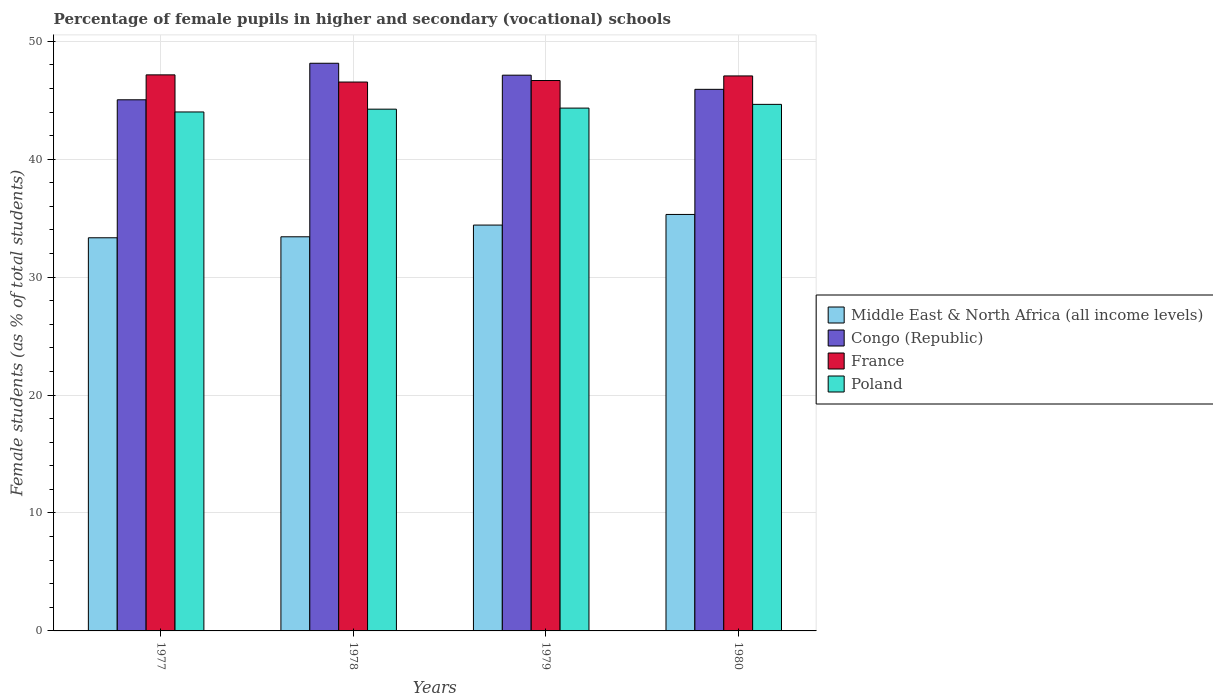How many groups of bars are there?
Provide a short and direct response. 4. Are the number of bars on each tick of the X-axis equal?
Ensure brevity in your answer.  Yes. How many bars are there on the 2nd tick from the left?
Keep it short and to the point. 4. In how many cases, is the number of bars for a given year not equal to the number of legend labels?
Provide a short and direct response. 0. What is the percentage of female pupils in higher and secondary schools in Middle East & North Africa (all income levels) in 1980?
Provide a succinct answer. 35.31. Across all years, what is the maximum percentage of female pupils in higher and secondary schools in Middle East & North Africa (all income levels)?
Offer a very short reply. 35.31. Across all years, what is the minimum percentage of female pupils in higher and secondary schools in Congo (Republic)?
Provide a short and direct response. 45.04. In which year was the percentage of female pupils in higher and secondary schools in Poland maximum?
Offer a terse response. 1980. In which year was the percentage of female pupils in higher and secondary schools in France minimum?
Provide a short and direct response. 1978. What is the total percentage of female pupils in higher and secondary schools in France in the graph?
Offer a terse response. 187.42. What is the difference between the percentage of female pupils in higher and secondary schools in Congo (Republic) in 1977 and that in 1979?
Ensure brevity in your answer.  -2.09. What is the difference between the percentage of female pupils in higher and secondary schools in Middle East & North Africa (all income levels) in 1977 and the percentage of female pupils in higher and secondary schools in Congo (Republic) in 1978?
Offer a very short reply. -14.8. What is the average percentage of female pupils in higher and secondary schools in Congo (Republic) per year?
Provide a short and direct response. 46.55. In the year 1979, what is the difference between the percentage of female pupils in higher and secondary schools in Congo (Republic) and percentage of female pupils in higher and secondary schools in Middle East & North Africa (all income levels)?
Provide a short and direct response. 12.71. In how many years, is the percentage of female pupils in higher and secondary schools in France greater than 42 %?
Provide a succinct answer. 4. What is the ratio of the percentage of female pupils in higher and secondary schools in France in 1979 to that in 1980?
Your answer should be compact. 0.99. What is the difference between the highest and the second highest percentage of female pupils in higher and secondary schools in Congo (Republic)?
Your response must be concise. 1.01. What is the difference between the highest and the lowest percentage of female pupils in higher and secondary schools in Poland?
Give a very brief answer. 0.64. In how many years, is the percentage of female pupils in higher and secondary schools in Congo (Republic) greater than the average percentage of female pupils in higher and secondary schools in Congo (Republic) taken over all years?
Ensure brevity in your answer.  2. Is it the case that in every year, the sum of the percentage of female pupils in higher and secondary schools in France and percentage of female pupils in higher and secondary schools in Middle East & North Africa (all income levels) is greater than the sum of percentage of female pupils in higher and secondary schools in Congo (Republic) and percentage of female pupils in higher and secondary schools in Poland?
Ensure brevity in your answer.  Yes. What does the 1st bar from the left in 1977 represents?
Make the answer very short. Middle East & North Africa (all income levels). What does the 3rd bar from the right in 1979 represents?
Give a very brief answer. Congo (Republic). How many years are there in the graph?
Give a very brief answer. 4. Where does the legend appear in the graph?
Your answer should be compact. Center right. How are the legend labels stacked?
Offer a terse response. Vertical. What is the title of the graph?
Your answer should be compact. Percentage of female pupils in higher and secondary (vocational) schools. What is the label or title of the X-axis?
Your answer should be compact. Years. What is the label or title of the Y-axis?
Offer a very short reply. Female students (as % of total students). What is the Female students (as % of total students) of Middle East & North Africa (all income levels) in 1977?
Your answer should be compact. 33.34. What is the Female students (as % of total students) in Congo (Republic) in 1977?
Give a very brief answer. 45.04. What is the Female students (as % of total students) of France in 1977?
Ensure brevity in your answer.  47.15. What is the Female students (as % of total students) in Poland in 1977?
Your answer should be compact. 44. What is the Female students (as % of total students) in Middle East & North Africa (all income levels) in 1978?
Make the answer very short. 33.42. What is the Female students (as % of total students) of Congo (Republic) in 1978?
Your response must be concise. 48.13. What is the Female students (as % of total students) of France in 1978?
Your answer should be very brief. 46.54. What is the Female students (as % of total students) in Poland in 1978?
Your response must be concise. 44.24. What is the Female students (as % of total students) in Middle East & North Africa (all income levels) in 1979?
Offer a very short reply. 34.41. What is the Female students (as % of total students) of Congo (Republic) in 1979?
Your answer should be compact. 47.12. What is the Female students (as % of total students) of France in 1979?
Ensure brevity in your answer.  46.67. What is the Female students (as % of total students) in Poland in 1979?
Provide a succinct answer. 44.33. What is the Female students (as % of total students) of Middle East & North Africa (all income levels) in 1980?
Make the answer very short. 35.31. What is the Female students (as % of total students) of Congo (Republic) in 1980?
Provide a succinct answer. 45.92. What is the Female students (as % of total students) of France in 1980?
Your response must be concise. 47.06. What is the Female students (as % of total students) in Poland in 1980?
Offer a very short reply. 44.65. Across all years, what is the maximum Female students (as % of total students) of Middle East & North Africa (all income levels)?
Make the answer very short. 35.31. Across all years, what is the maximum Female students (as % of total students) of Congo (Republic)?
Make the answer very short. 48.13. Across all years, what is the maximum Female students (as % of total students) in France?
Provide a succinct answer. 47.15. Across all years, what is the maximum Female students (as % of total students) of Poland?
Make the answer very short. 44.65. Across all years, what is the minimum Female students (as % of total students) in Middle East & North Africa (all income levels)?
Your answer should be compact. 33.34. Across all years, what is the minimum Female students (as % of total students) in Congo (Republic)?
Give a very brief answer. 45.04. Across all years, what is the minimum Female students (as % of total students) in France?
Your answer should be compact. 46.54. Across all years, what is the minimum Female students (as % of total students) of Poland?
Offer a very short reply. 44. What is the total Female students (as % of total students) of Middle East & North Africa (all income levels) in the graph?
Your answer should be compact. 136.48. What is the total Female students (as % of total students) in Congo (Republic) in the graph?
Make the answer very short. 186.21. What is the total Female students (as % of total students) in France in the graph?
Your answer should be very brief. 187.42. What is the total Female students (as % of total students) of Poland in the graph?
Keep it short and to the point. 177.23. What is the difference between the Female students (as % of total students) of Middle East & North Africa (all income levels) in 1977 and that in 1978?
Your answer should be very brief. -0.08. What is the difference between the Female students (as % of total students) of Congo (Republic) in 1977 and that in 1978?
Provide a succinct answer. -3.1. What is the difference between the Female students (as % of total students) in France in 1977 and that in 1978?
Ensure brevity in your answer.  0.61. What is the difference between the Female students (as % of total students) in Poland in 1977 and that in 1978?
Your answer should be very brief. -0.24. What is the difference between the Female students (as % of total students) in Middle East & North Africa (all income levels) in 1977 and that in 1979?
Give a very brief answer. -1.08. What is the difference between the Female students (as % of total students) in Congo (Republic) in 1977 and that in 1979?
Offer a terse response. -2.09. What is the difference between the Female students (as % of total students) in France in 1977 and that in 1979?
Make the answer very short. 0.48. What is the difference between the Female students (as % of total students) in Poland in 1977 and that in 1979?
Ensure brevity in your answer.  -0.33. What is the difference between the Female students (as % of total students) of Middle East & North Africa (all income levels) in 1977 and that in 1980?
Your answer should be very brief. -1.98. What is the difference between the Female students (as % of total students) of Congo (Republic) in 1977 and that in 1980?
Offer a terse response. -0.89. What is the difference between the Female students (as % of total students) in France in 1977 and that in 1980?
Offer a terse response. 0.09. What is the difference between the Female students (as % of total students) of Poland in 1977 and that in 1980?
Provide a short and direct response. -0.64. What is the difference between the Female students (as % of total students) in Middle East & North Africa (all income levels) in 1978 and that in 1979?
Offer a very short reply. -0.99. What is the difference between the Female students (as % of total students) of Congo (Republic) in 1978 and that in 1979?
Make the answer very short. 1.01. What is the difference between the Female students (as % of total students) of France in 1978 and that in 1979?
Offer a terse response. -0.13. What is the difference between the Female students (as % of total students) of Poland in 1978 and that in 1979?
Make the answer very short. -0.09. What is the difference between the Female students (as % of total students) in Middle East & North Africa (all income levels) in 1978 and that in 1980?
Provide a short and direct response. -1.89. What is the difference between the Female students (as % of total students) in Congo (Republic) in 1978 and that in 1980?
Make the answer very short. 2.21. What is the difference between the Female students (as % of total students) in France in 1978 and that in 1980?
Your response must be concise. -0.52. What is the difference between the Female students (as % of total students) in Poland in 1978 and that in 1980?
Ensure brevity in your answer.  -0.41. What is the difference between the Female students (as % of total students) in Middle East & North Africa (all income levels) in 1979 and that in 1980?
Ensure brevity in your answer.  -0.9. What is the difference between the Female students (as % of total students) of Congo (Republic) in 1979 and that in 1980?
Give a very brief answer. 1.2. What is the difference between the Female students (as % of total students) of France in 1979 and that in 1980?
Your response must be concise. -0.39. What is the difference between the Female students (as % of total students) of Poland in 1979 and that in 1980?
Your answer should be compact. -0.32. What is the difference between the Female students (as % of total students) in Middle East & North Africa (all income levels) in 1977 and the Female students (as % of total students) in Congo (Republic) in 1978?
Your response must be concise. -14.8. What is the difference between the Female students (as % of total students) in Middle East & North Africa (all income levels) in 1977 and the Female students (as % of total students) in France in 1978?
Ensure brevity in your answer.  -13.21. What is the difference between the Female students (as % of total students) of Middle East & North Africa (all income levels) in 1977 and the Female students (as % of total students) of Poland in 1978?
Your response must be concise. -10.91. What is the difference between the Female students (as % of total students) of Congo (Republic) in 1977 and the Female students (as % of total students) of France in 1978?
Your response must be concise. -1.51. What is the difference between the Female students (as % of total students) in Congo (Republic) in 1977 and the Female students (as % of total students) in Poland in 1978?
Your response must be concise. 0.79. What is the difference between the Female students (as % of total students) of France in 1977 and the Female students (as % of total students) of Poland in 1978?
Provide a short and direct response. 2.91. What is the difference between the Female students (as % of total students) in Middle East & North Africa (all income levels) in 1977 and the Female students (as % of total students) in Congo (Republic) in 1979?
Offer a very short reply. -13.79. What is the difference between the Female students (as % of total students) in Middle East & North Africa (all income levels) in 1977 and the Female students (as % of total students) in France in 1979?
Offer a very short reply. -13.33. What is the difference between the Female students (as % of total students) of Middle East & North Africa (all income levels) in 1977 and the Female students (as % of total students) of Poland in 1979?
Your answer should be very brief. -11. What is the difference between the Female students (as % of total students) of Congo (Republic) in 1977 and the Female students (as % of total students) of France in 1979?
Offer a very short reply. -1.63. What is the difference between the Female students (as % of total students) of Congo (Republic) in 1977 and the Female students (as % of total students) of Poland in 1979?
Make the answer very short. 0.7. What is the difference between the Female students (as % of total students) in France in 1977 and the Female students (as % of total students) in Poland in 1979?
Offer a terse response. 2.82. What is the difference between the Female students (as % of total students) in Middle East & North Africa (all income levels) in 1977 and the Female students (as % of total students) in Congo (Republic) in 1980?
Your answer should be compact. -12.59. What is the difference between the Female students (as % of total students) in Middle East & North Africa (all income levels) in 1977 and the Female students (as % of total students) in France in 1980?
Offer a very short reply. -13.72. What is the difference between the Female students (as % of total students) in Middle East & North Africa (all income levels) in 1977 and the Female students (as % of total students) in Poland in 1980?
Provide a short and direct response. -11.31. What is the difference between the Female students (as % of total students) in Congo (Republic) in 1977 and the Female students (as % of total students) in France in 1980?
Make the answer very short. -2.02. What is the difference between the Female students (as % of total students) of Congo (Republic) in 1977 and the Female students (as % of total students) of Poland in 1980?
Your response must be concise. 0.39. What is the difference between the Female students (as % of total students) in France in 1977 and the Female students (as % of total students) in Poland in 1980?
Ensure brevity in your answer.  2.5. What is the difference between the Female students (as % of total students) of Middle East & North Africa (all income levels) in 1978 and the Female students (as % of total students) of Congo (Republic) in 1979?
Provide a short and direct response. -13.7. What is the difference between the Female students (as % of total students) in Middle East & North Africa (all income levels) in 1978 and the Female students (as % of total students) in France in 1979?
Provide a succinct answer. -13.25. What is the difference between the Female students (as % of total students) in Middle East & North Africa (all income levels) in 1978 and the Female students (as % of total students) in Poland in 1979?
Provide a short and direct response. -10.91. What is the difference between the Female students (as % of total students) in Congo (Republic) in 1978 and the Female students (as % of total students) in France in 1979?
Your response must be concise. 1.46. What is the difference between the Female students (as % of total students) in Congo (Republic) in 1978 and the Female students (as % of total students) in Poland in 1979?
Keep it short and to the point. 3.8. What is the difference between the Female students (as % of total students) of France in 1978 and the Female students (as % of total students) of Poland in 1979?
Your answer should be very brief. 2.21. What is the difference between the Female students (as % of total students) in Middle East & North Africa (all income levels) in 1978 and the Female students (as % of total students) in Congo (Republic) in 1980?
Offer a very short reply. -12.5. What is the difference between the Female students (as % of total students) in Middle East & North Africa (all income levels) in 1978 and the Female students (as % of total students) in France in 1980?
Provide a succinct answer. -13.64. What is the difference between the Female students (as % of total students) of Middle East & North Africa (all income levels) in 1978 and the Female students (as % of total students) of Poland in 1980?
Offer a very short reply. -11.23. What is the difference between the Female students (as % of total students) of Congo (Republic) in 1978 and the Female students (as % of total students) of France in 1980?
Make the answer very short. 1.08. What is the difference between the Female students (as % of total students) of Congo (Republic) in 1978 and the Female students (as % of total students) of Poland in 1980?
Make the answer very short. 3.49. What is the difference between the Female students (as % of total students) in France in 1978 and the Female students (as % of total students) in Poland in 1980?
Offer a very short reply. 1.89. What is the difference between the Female students (as % of total students) of Middle East & North Africa (all income levels) in 1979 and the Female students (as % of total students) of Congo (Republic) in 1980?
Offer a very short reply. -11.51. What is the difference between the Female students (as % of total students) in Middle East & North Africa (all income levels) in 1979 and the Female students (as % of total students) in France in 1980?
Provide a succinct answer. -12.65. What is the difference between the Female students (as % of total students) in Middle East & North Africa (all income levels) in 1979 and the Female students (as % of total students) in Poland in 1980?
Offer a very short reply. -10.23. What is the difference between the Female students (as % of total students) of Congo (Republic) in 1979 and the Female students (as % of total students) of France in 1980?
Provide a short and direct response. 0.06. What is the difference between the Female students (as % of total students) in Congo (Republic) in 1979 and the Female students (as % of total students) in Poland in 1980?
Provide a succinct answer. 2.47. What is the difference between the Female students (as % of total students) in France in 1979 and the Female students (as % of total students) in Poland in 1980?
Provide a short and direct response. 2.02. What is the average Female students (as % of total students) in Middle East & North Africa (all income levels) per year?
Keep it short and to the point. 34.12. What is the average Female students (as % of total students) of Congo (Republic) per year?
Offer a terse response. 46.55. What is the average Female students (as % of total students) of France per year?
Keep it short and to the point. 46.86. What is the average Female students (as % of total students) of Poland per year?
Provide a succinct answer. 44.31. In the year 1977, what is the difference between the Female students (as % of total students) of Middle East & North Africa (all income levels) and Female students (as % of total students) of Congo (Republic)?
Your response must be concise. -11.7. In the year 1977, what is the difference between the Female students (as % of total students) of Middle East & North Africa (all income levels) and Female students (as % of total students) of France?
Ensure brevity in your answer.  -13.81. In the year 1977, what is the difference between the Female students (as % of total students) in Middle East & North Africa (all income levels) and Female students (as % of total students) in Poland?
Offer a very short reply. -10.67. In the year 1977, what is the difference between the Female students (as % of total students) in Congo (Republic) and Female students (as % of total students) in France?
Offer a very short reply. -2.11. In the year 1977, what is the difference between the Female students (as % of total students) of Congo (Republic) and Female students (as % of total students) of Poland?
Make the answer very short. 1.03. In the year 1977, what is the difference between the Female students (as % of total students) of France and Female students (as % of total students) of Poland?
Keep it short and to the point. 3.15. In the year 1978, what is the difference between the Female students (as % of total students) in Middle East & North Africa (all income levels) and Female students (as % of total students) in Congo (Republic)?
Provide a succinct answer. -14.71. In the year 1978, what is the difference between the Female students (as % of total students) of Middle East & North Africa (all income levels) and Female students (as % of total students) of France?
Give a very brief answer. -13.12. In the year 1978, what is the difference between the Female students (as % of total students) in Middle East & North Africa (all income levels) and Female students (as % of total students) in Poland?
Provide a succinct answer. -10.82. In the year 1978, what is the difference between the Female students (as % of total students) of Congo (Republic) and Female students (as % of total students) of France?
Keep it short and to the point. 1.59. In the year 1978, what is the difference between the Female students (as % of total students) in Congo (Republic) and Female students (as % of total students) in Poland?
Ensure brevity in your answer.  3.89. In the year 1978, what is the difference between the Female students (as % of total students) of France and Female students (as % of total students) of Poland?
Your response must be concise. 2.3. In the year 1979, what is the difference between the Female students (as % of total students) in Middle East & North Africa (all income levels) and Female students (as % of total students) in Congo (Republic)?
Keep it short and to the point. -12.71. In the year 1979, what is the difference between the Female students (as % of total students) of Middle East & North Africa (all income levels) and Female students (as % of total students) of France?
Keep it short and to the point. -12.26. In the year 1979, what is the difference between the Female students (as % of total students) of Middle East & North Africa (all income levels) and Female students (as % of total students) of Poland?
Provide a succinct answer. -9.92. In the year 1979, what is the difference between the Female students (as % of total students) of Congo (Republic) and Female students (as % of total students) of France?
Your response must be concise. 0.45. In the year 1979, what is the difference between the Female students (as % of total students) in Congo (Republic) and Female students (as % of total students) in Poland?
Your response must be concise. 2.79. In the year 1979, what is the difference between the Female students (as % of total students) of France and Female students (as % of total students) of Poland?
Offer a terse response. 2.34. In the year 1980, what is the difference between the Female students (as % of total students) of Middle East & North Africa (all income levels) and Female students (as % of total students) of Congo (Republic)?
Your answer should be compact. -10.61. In the year 1980, what is the difference between the Female students (as % of total students) in Middle East & North Africa (all income levels) and Female students (as % of total students) in France?
Offer a terse response. -11.74. In the year 1980, what is the difference between the Female students (as % of total students) of Middle East & North Africa (all income levels) and Female students (as % of total students) of Poland?
Your answer should be compact. -9.33. In the year 1980, what is the difference between the Female students (as % of total students) in Congo (Republic) and Female students (as % of total students) in France?
Give a very brief answer. -1.14. In the year 1980, what is the difference between the Female students (as % of total students) in Congo (Republic) and Female students (as % of total students) in Poland?
Make the answer very short. 1.27. In the year 1980, what is the difference between the Female students (as % of total students) of France and Female students (as % of total students) of Poland?
Offer a terse response. 2.41. What is the ratio of the Female students (as % of total students) in Middle East & North Africa (all income levels) in 1977 to that in 1978?
Offer a terse response. 1. What is the ratio of the Female students (as % of total students) of Congo (Republic) in 1977 to that in 1978?
Your answer should be compact. 0.94. What is the ratio of the Female students (as % of total students) in France in 1977 to that in 1978?
Provide a short and direct response. 1.01. What is the ratio of the Female students (as % of total students) of Middle East & North Africa (all income levels) in 1977 to that in 1979?
Offer a very short reply. 0.97. What is the ratio of the Female students (as % of total students) of Congo (Republic) in 1977 to that in 1979?
Your answer should be compact. 0.96. What is the ratio of the Female students (as % of total students) in France in 1977 to that in 1979?
Provide a short and direct response. 1.01. What is the ratio of the Female students (as % of total students) in Poland in 1977 to that in 1979?
Offer a terse response. 0.99. What is the ratio of the Female students (as % of total students) in Middle East & North Africa (all income levels) in 1977 to that in 1980?
Provide a succinct answer. 0.94. What is the ratio of the Female students (as % of total students) of Congo (Republic) in 1977 to that in 1980?
Give a very brief answer. 0.98. What is the ratio of the Female students (as % of total students) of France in 1977 to that in 1980?
Give a very brief answer. 1. What is the ratio of the Female students (as % of total students) in Poland in 1977 to that in 1980?
Your answer should be compact. 0.99. What is the ratio of the Female students (as % of total students) of Middle East & North Africa (all income levels) in 1978 to that in 1979?
Your answer should be very brief. 0.97. What is the ratio of the Female students (as % of total students) of Congo (Republic) in 1978 to that in 1979?
Make the answer very short. 1.02. What is the ratio of the Female students (as % of total students) of France in 1978 to that in 1979?
Offer a terse response. 1. What is the ratio of the Female students (as % of total students) of Poland in 1978 to that in 1979?
Offer a very short reply. 1. What is the ratio of the Female students (as % of total students) of Middle East & North Africa (all income levels) in 1978 to that in 1980?
Your response must be concise. 0.95. What is the ratio of the Female students (as % of total students) in Congo (Republic) in 1978 to that in 1980?
Provide a short and direct response. 1.05. What is the ratio of the Female students (as % of total students) of France in 1978 to that in 1980?
Ensure brevity in your answer.  0.99. What is the ratio of the Female students (as % of total students) of Poland in 1978 to that in 1980?
Provide a succinct answer. 0.99. What is the ratio of the Female students (as % of total students) of Middle East & North Africa (all income levels) in 1979 to that in 1980?
Provide a short and direct response. 0.97. What is the ratio of the Female students (as % of total students) of Congo (Republic) in 1979 to that in 1980?
Make the answer very short. 1.03. What is the difference between the highest and the second highest Female students (as % of total students) of Middle East & North Africa (all income levels)?
Provide a short and direct response. 0.9. What is the difference between the highest and the second highest Female students (as % of total students) of Congo (Republic)?
Offer a very short reply. 1.01. What is the difference between the highest and the second highest Female students (as % of total students) of France?
Ensure brevity in your answer.  0.09. What is the difference between the highest and the second highest Female students (as % of total students) in Poland?
Your response must be concise. 0.32. What is the difference between the highest and the lowest Female students (as % of total students) of Middle East & North Africa (all income levels)?
Give a very brief answer. 1.98. What is the difference between the highest and the lowest Female students (as % of total students) in Congo (Republic)?
Provide a short and direct response. 3.1. What is the difference between the highest and the lowest Female students (as % of total students) in France?
Ensure brevity in your answer.  0.61. What is the difference between the highest and the lowest Female students (as % of total students) of Poland?
Keep it short and to the point. 0.64. 